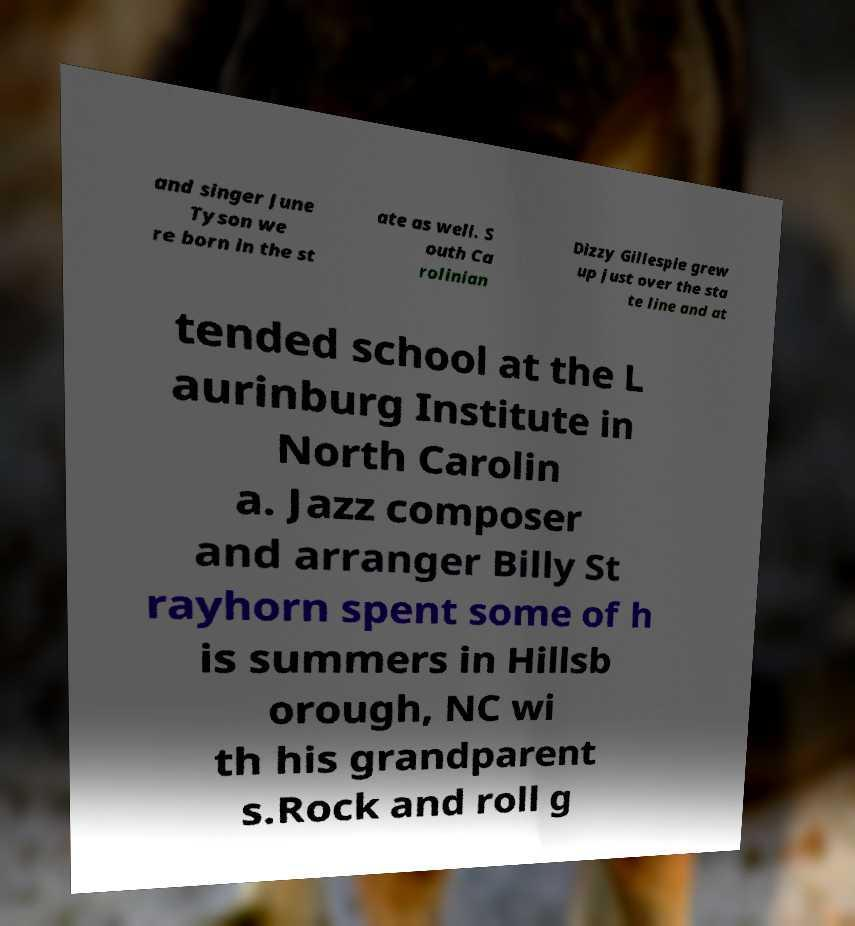There's text embedded in this image that I need extracted. Can you transcribe it verbatim? and singer June Tyson we re born in the st ate as well. S outh Ca rolinian Dizzy Gillespie grew up just over the sta te line and at tended school at the L aurinburg Institute in North Carolin a. Jazz composer and arranger Billy St rayhorn spent some of h is summers in Hillsb orough, NC wi th his grandparent s.Rock and roll g 